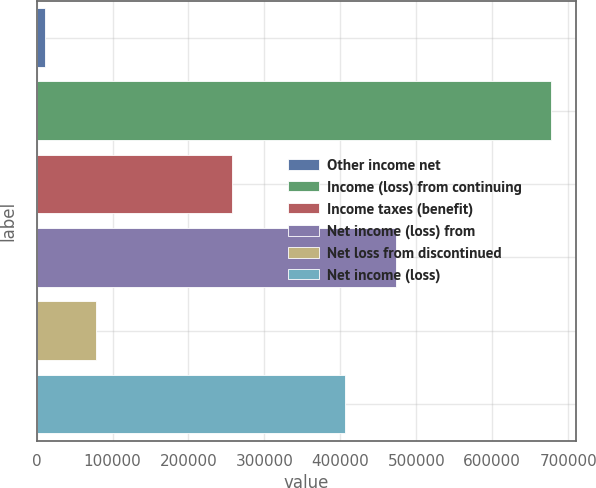Convert chart. <chart><loc_0><loc_0><loc_500><loc_500><bar_chart><fcel>Other income net<fcel>Income (loss) from continuing<fcel>Income taxes (benefit)<fcel>Net income (loss) from<fcel>Net loss from discontinued<fcel>Net income (loss)<nl><fcel>11455<fcel>677025<fcel>257620<fcel>472667<fcel>78012<fcel>406110<nl></chart> 